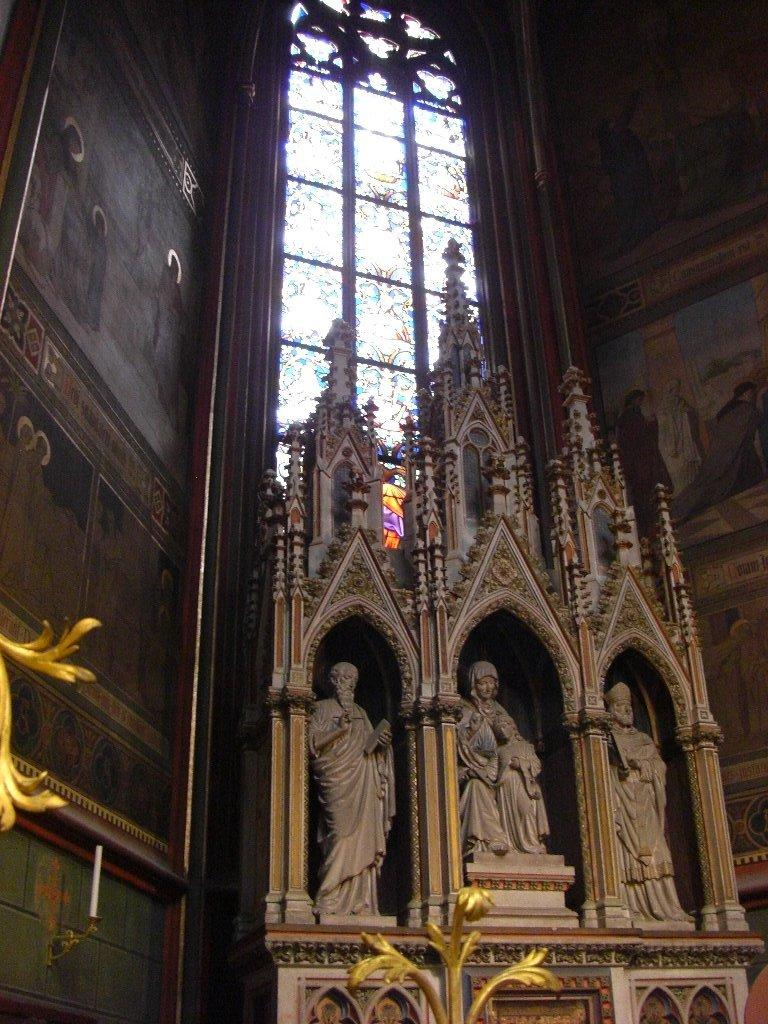What can be seen in the image that represents artistic creations? There are statues in the image. What is visible in the background of the image? There is a wall with paintings and a window in the background of the image. What type of letter can be seen hanging from the bell in the image? There is no bell or letter present in the image. 